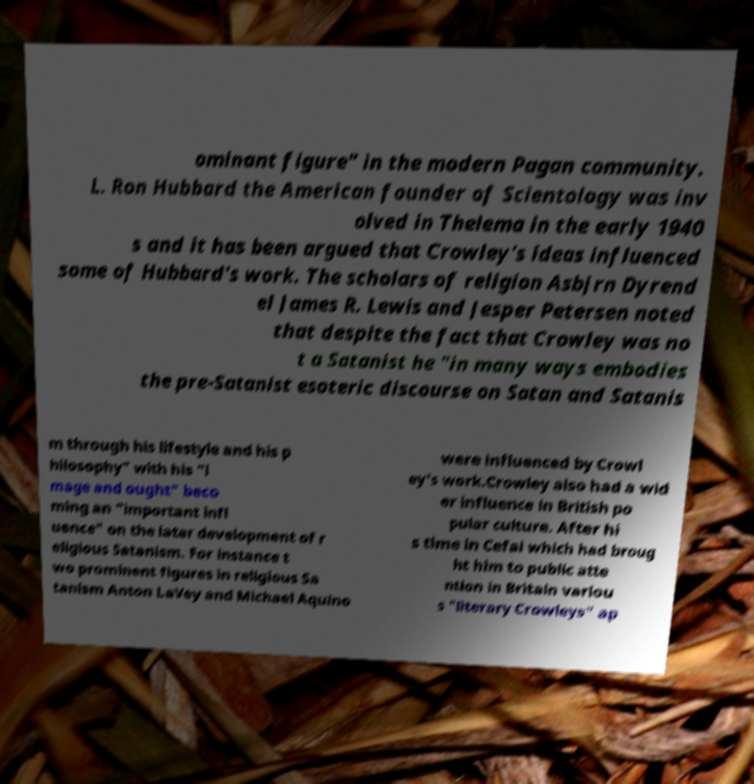Please identify and transcribe the text found in this image. ominant figure" in the modern Pagan community. L. Ron Hubbard the American founder of Scientology was inv olved in Thelema in the early 1940 s and it has been argued that Crowley's ideas influenced some of Hubbard's work. The scholars of religion Asbjrn Dyrend el James R. Lewis and Jesper Petersen noted that despite the fact that Crowley was no t a Satanist he "in many ways embodies the pre-Satanist esoteric discourse on Satan and Satanis m through his lifestyle and his p hilosophy" with his "i mage and ought" beco ming an "important infl uence" on the later development of r eligious Satanism. For instance t wo prominent figures in religious Sa tanism Anton LaVey and Michael Aquino were influenced by Crowl ey's work.Crowley also had a wid er influence in British po pular culture. After hi s time in Cefal which had broug ht him to public atte ntion in Britain variou s "literary Crowleys" ap 